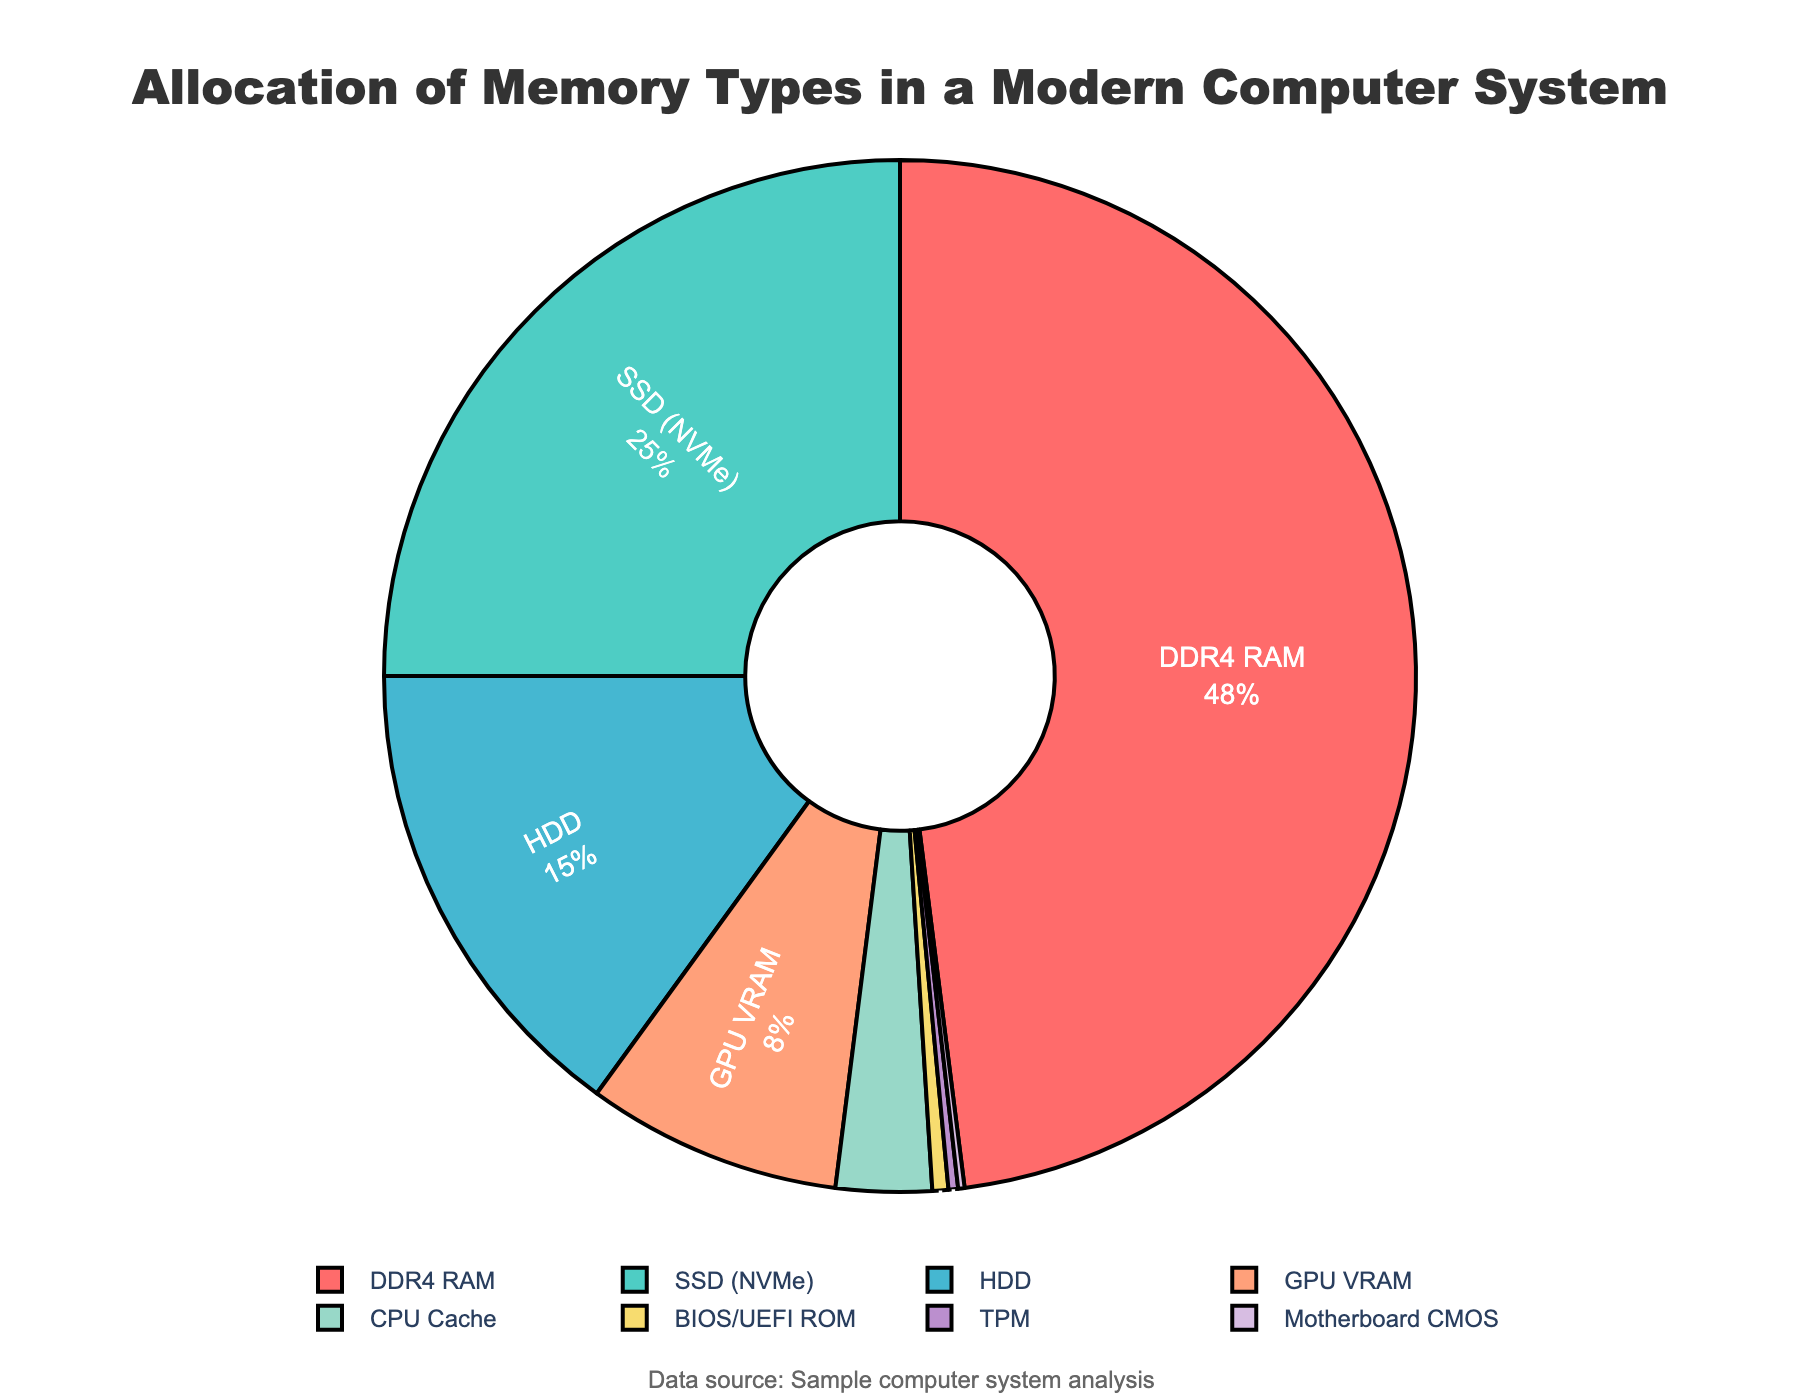What percentage of the memory types does DDR4 RAM contribute? From the figure, locate the section labeled "DDR4 RAM" and refer to the percentage shown next to it.
Answer: 48% What is the combined percentage of SSD (NVMe) and HDD? Add the percentages provided for SSD (NVMe) and HDD. SSD (NVMe) is 25% and HDD is 15%, so 25% + 15% = 40%.
Answer: 40% Which memory type has the smallest allocation, and what is its percentage? Find the segment with the smallest percentage. The smallest slice in the pie chart is labeled "Motherboard CMOS" with a percentage of 0.2%.
Answer: Motherboard CMOS, 0.2% How does the GPU VRAM's allocation compare to the CPU Cache's allocation? Compare the GPU VRAM's 8% to the CPU Cache's 3%. Since 8% is greater than 3%, GPU VRAM's allocation is larger.
Answer: GPU VRAM is greater What is the difference in memory allocation between DDR4 RAM and SSD (NVMe)? Subtract the percentage of SSD (NVMe) from DDR4 RAM. DDR4 RAM is 48% and SSD (NVMe) is 25%, so 48% - 25% = 23%.
Answer: 23% What proportion of the total memory allocation is occupied by BIOS/UEFI ROM relative to the total? Reference the BIOS/UEFI ROM section's percentage which is 0.5% of the total memory allocation.
Answer: 0.5% What is the total percentage allocation of the given memory types excluding DDR4 RAM and SSD (NVMe)? Sum up the percentages of all types except DDR4 RAM and SSD (NVMe). That means adding 15% (HDD) + 8% (GPU VRAM) + 3% (CPU Cache) + 0.5% (BIOS/UEFI ROM) + 0.3% (TPM) + 0.2% (Motherboard CMOS) = 27%.
Answer: 27% Which three memory types together make up more than 50% of the total memory allocation? Add the percentages in descending order until surpassing 50%. DDR4 RAM is 48%, SSD (NVMe) is 25%, totaling 73%, both together exceed 50%. Including HDD makes it 88%. So, DDR4 RAM, SSD (NVMe), and HDD together surpass 50%.
Answer: DDR4 RAM, SSD (NVMe), HDD What is the sum of the allocations of CPU Cache and BIOS/UEFI ROM? Add the percentages of CPU Cache and BIOS/UEFI ROM. CPU Cache is 3%, and BIOS/UEFI ROM is 0.5%, so 3% + 0.5% = 3.5%.
Answer: 3.5% How many memory types have an allocation greater than 10%? Count the memory types with allocations greater than 10%. DDR4 RAM (48%) and SSD (NVMe) (25%) both exceed 10%, so there are two such types.
Answer: 2 